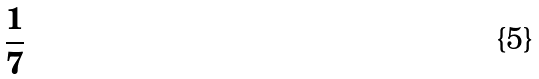<formula> <loc_0><loc_0><loc_500><loc_500>\frac { 1 } { 7 }</formula> 